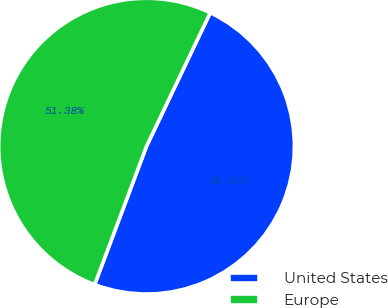<chart> <loc_0><loc_0><loc_500><loc_500><pie_chart><fcel>United States<fcel>Europe<nl><fcel>48.62%<fcel>51.38%<nl></chart> 